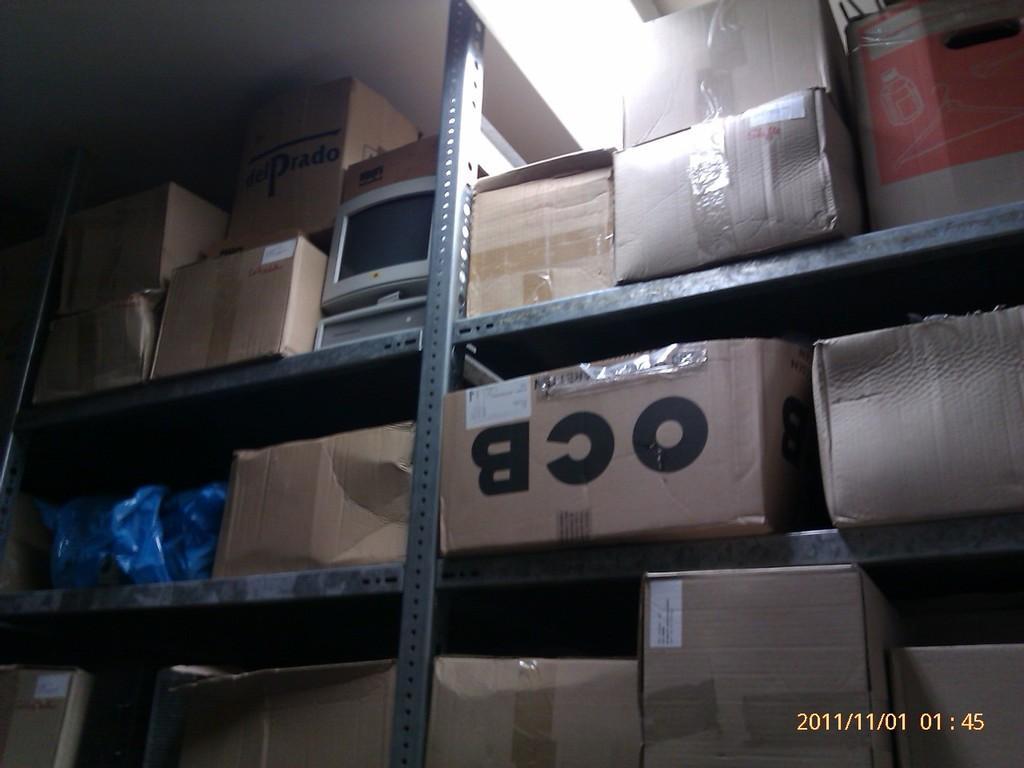Can you describe this image briefly? In the image there are storage racks and in each race there are some boxes. 